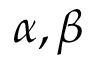<formula> <loc_0><loc_0><loc_500><loc_500>\alpha , \beta</formula> 